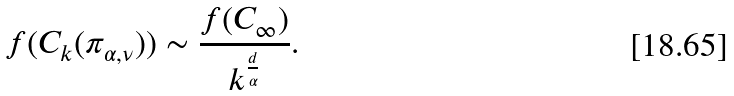<formula> <loc_0><loc_0><loc_500><loc_500>f ( C _ { k } ( \pi _ { \alpha , \nu } ) ) \sim \frac { f ( C _ { \infty } ) } { k ^ { \frac { d } { \alpha } } } .</formula> 